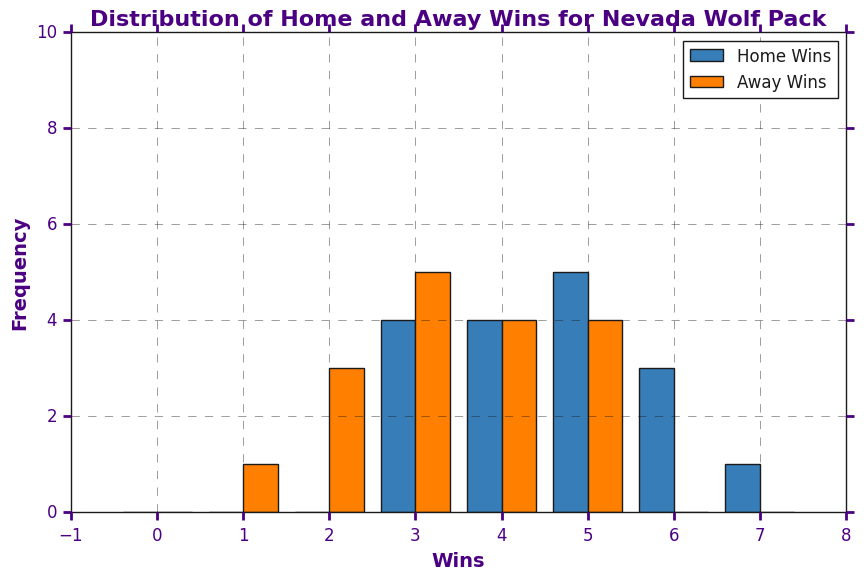How many times did the Nevada Wolf Pack have more Home Wins than Away Wins? Looking at the histogram, count the number of bins where Home Wins bars are higher than Away Wins bars.
Answer: 11 Which win category (Home or Away) has a more frequent maximum value? Identify the highest bar for each group (Home and Away) and compare their heights.
Answer: Away Wins What is the most common number of Home Wins? Find the highest bar in the Home Wins group and read the number on the x-axis it corresponds to.
Answer: 5 How many times did the Nevada Wolf Pack have zero Away Wins? Look at the x-axis label for zero in the Away Wins group and check if there is a corresponding bar.
Answer: 0 What's the difference in maximum frequency between Home Wins and Away Wins? Identify the highest bars for Home Wins and Away Wins, then subtract the smaller frequency from the larger frequency.
Answer: 2 Which group has a wider range of win counts? Compare the range of the x-axis values spanned by non-zero bins in both Home Wins and Away Wins groups.
Answer: Home Wins What is the median value of Home Wins? List all Home Wins values and find the middle value (or the average of the two middle values if even).
Answer: 5 Are there any win counts that have the same frequency for both Home and Away Wins? Compare the heights of the corresponding bars for Home and Away Wins on the same x-axis labels.
Answer: Yes, for 3 Wins Which win count has the least frequency in both Home and Away Wins? Look for the shortest bars in both groups and note the x-axis labels.
Answer: 7 (Home) and 1 (Away) What's the most common total number of wins (Home + Away)? Calculate total wins for each bin, add frequencies for total wins and find the highest frequency.
Answer: 8 